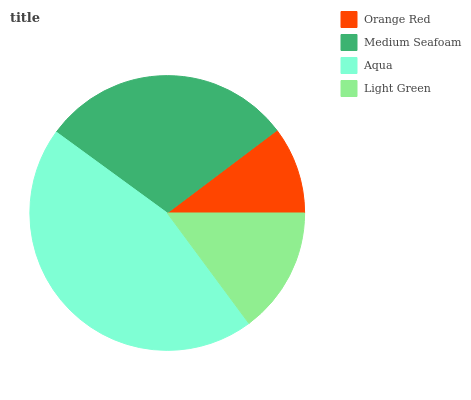Is Orange Red the minimum?
Answer yes or no. Yes. Is Aqua the maximum?
Answer yes or no. Yes. Is Medium Seafoam the minimum?
Answer yes or no. No. Is Medium Seafoam the maximum?
Answer yes or no. No. Is Medium Seafoam greater than Orange Red?
Answer yes or no. Yes. Is Orange Red less than Medium Seafoam?
Answer yes or no. Yes. Is Orange Red greater than Medium Seafoam?
Answer yes or no. No. Is Medium Seafoam less than Orange Red?
Answer yes or no. No. Is Medium Seafoam the high median?
Answer yes or no. Yes. Is Light Green the low median?
Answer yes or no. Yes. Is Orange Red the high median?
Answer yes or no. No. Is Orange Red the low median?
Answer yes or no. No. 